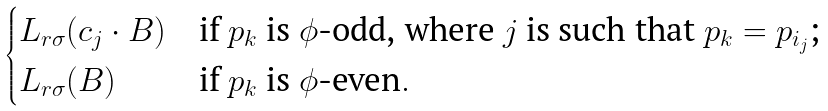Convert formula to latex. <formula><loc_0><loc_0><loc_500><loc_500>\begin{cases} L _ { r \sigma } ( c _ { j } \cdot B ) & \text {if $p_{k}$ is $\phi$-odd, where $j$ is such that $p_{k} = p_{i_{j}}$;} \\ L _ { r \sigma } ( B ) & \text {if $p_{k}$ is $\phi$-even} . \end{cases}</formula> 